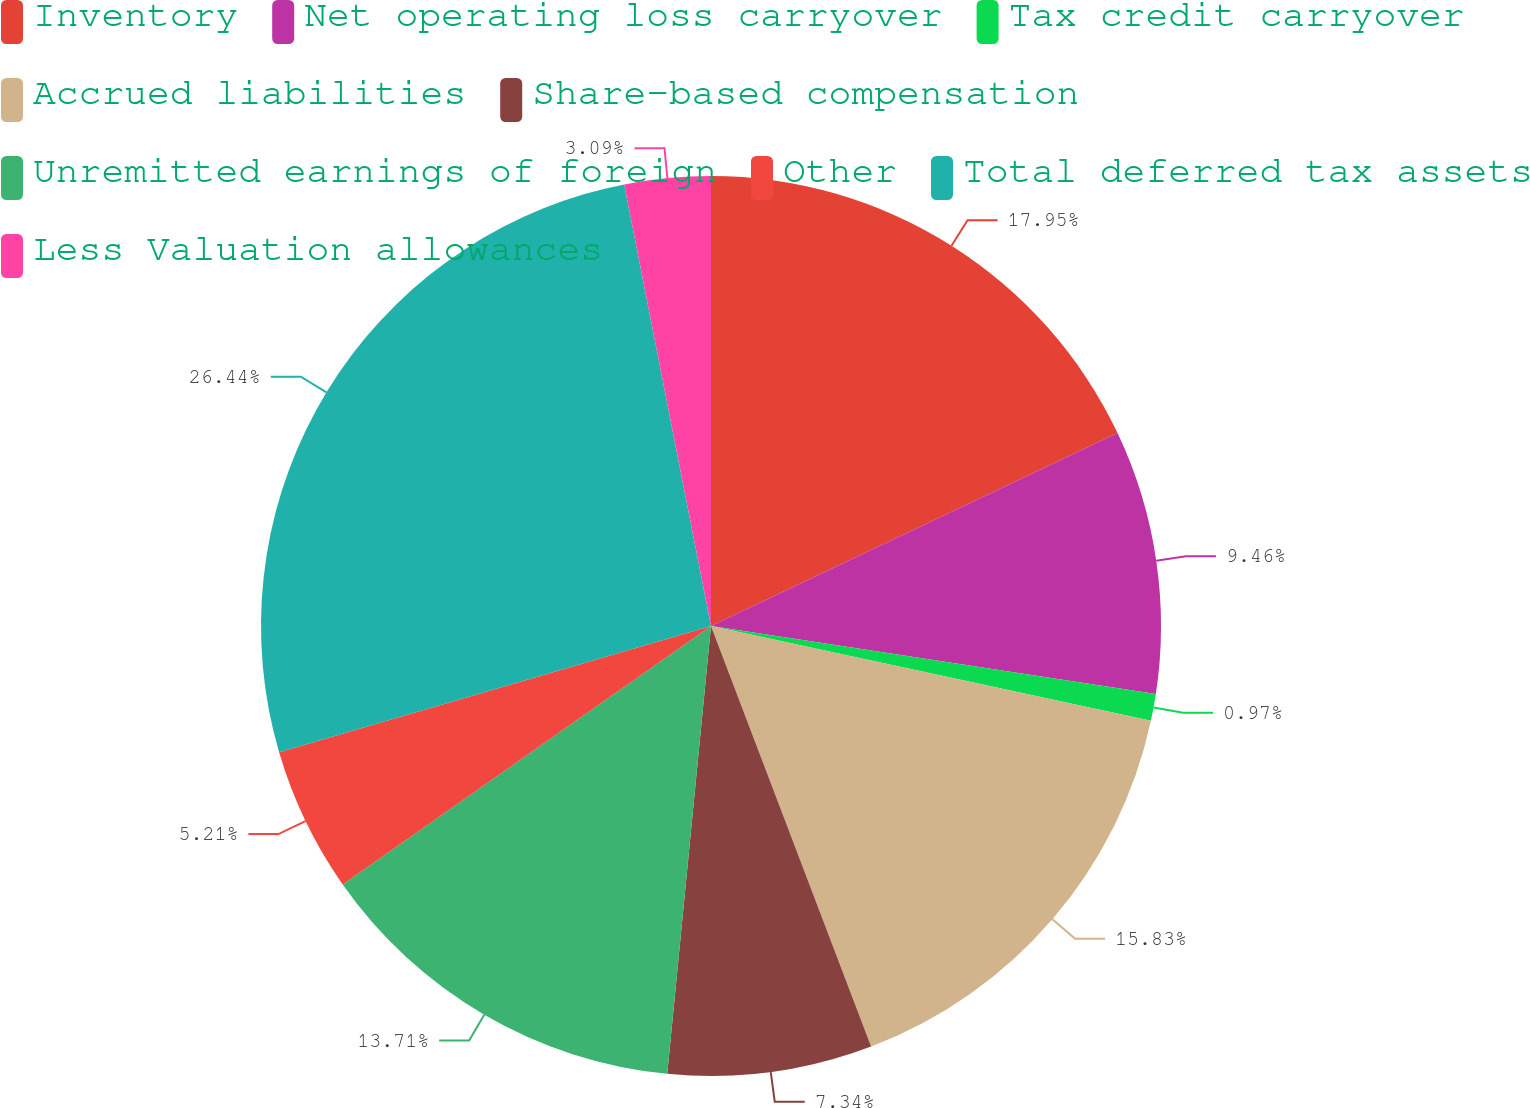<chart> <loc_0><loc_0><loc_500><loc_500><pie_chart><fcel>Inventory<fcel>Net operating loss carryover<fcel>Tax credit carryover<fcel>Accrued liabilities<fcel>Share-based compensation<fcel>Unremitted earnings of foreign<fcel>Other<fcel>Total deferred tax assets<fcel>Less Valuation allowances<nl><fcel>17.95%<fcel>9.46%<fcel>0.97%<fcel>15.83%<fcel>7.34%<fcel>13.71%<fcel>5.21%<fcel>26.44%<fcel>3.09%<nl></chart> 